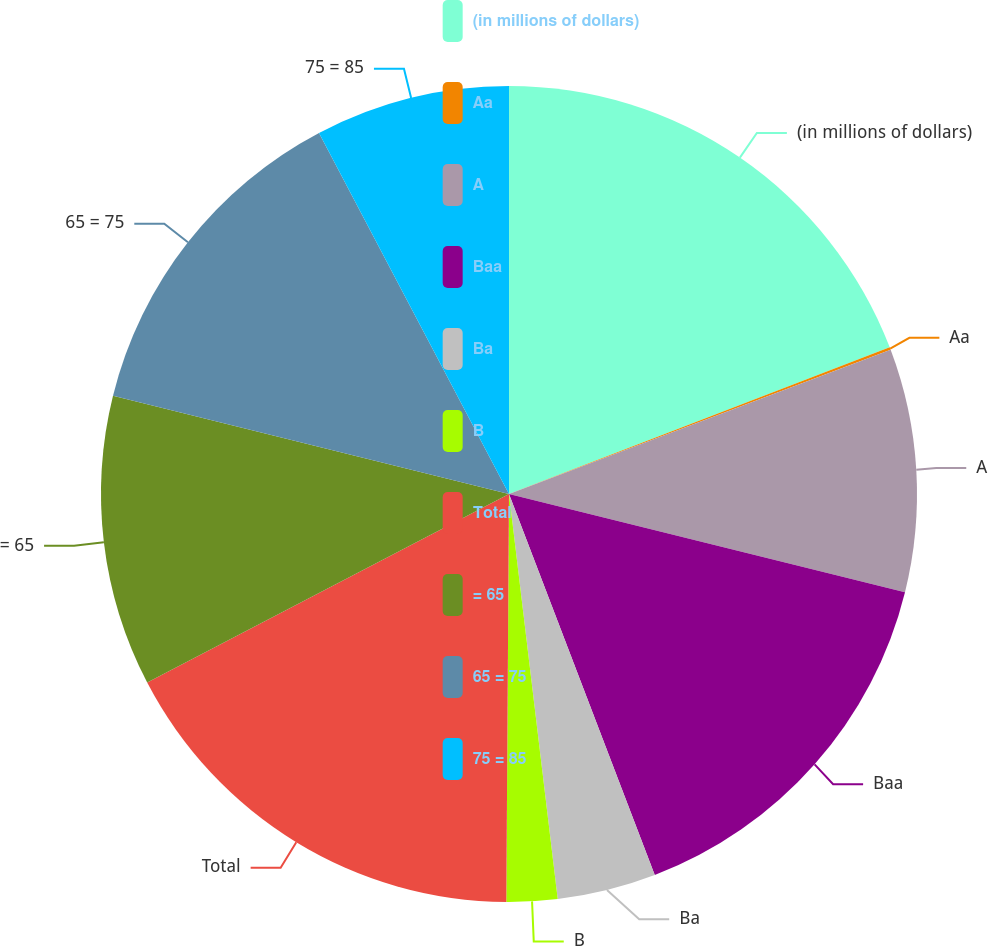Convert chart. <chart><loc_0><loc_0><loc_500><loc_500><pie_chart><fcel>(in millions of dollars)<fcel>Aa<fcel>A<fcel>Baa<fcel>Ba<fcel>B<fcel>Total<fcel>= 65<fcel>65 = 75<fcel>75 = 85<nl><fcel>19.15%<fcel>0.1%<fcel>9.62%<fcel>15.32%<fcel>3.91%<fcel>2.01%<fcel>17.25%<fcel>11.52%<fcel>13.42%<fcel>7.71%<nl></chart> 